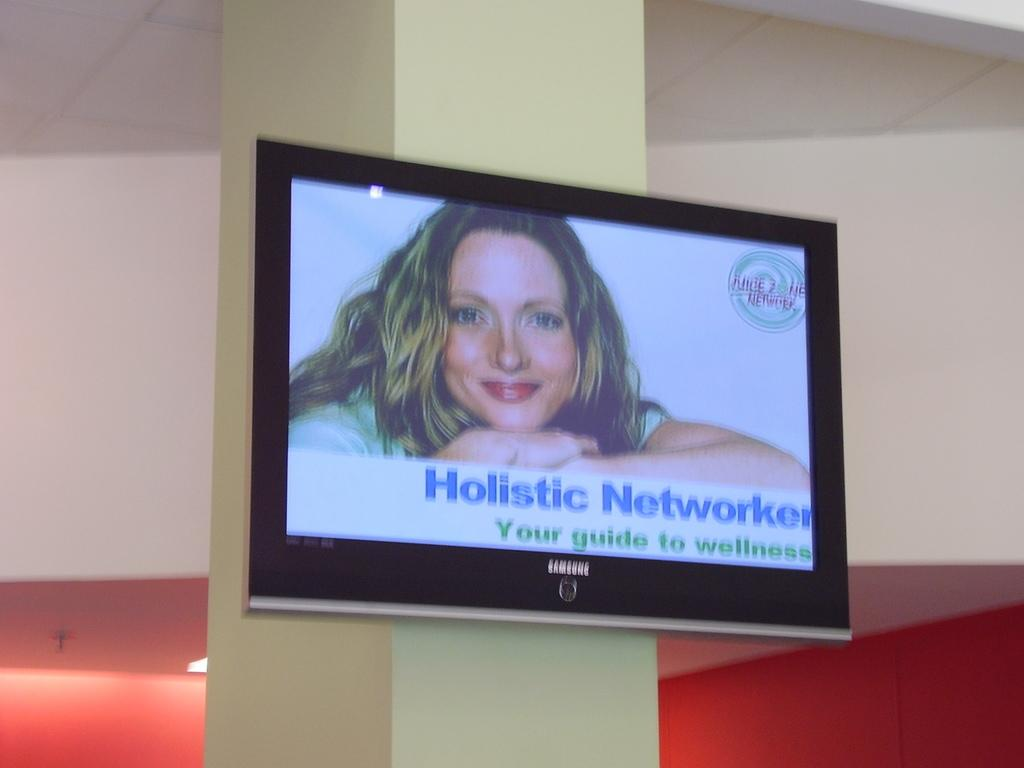<image>
Give a short and clear explanation of the subsequent image. A television screen shows an ad for a holistic network. 